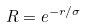Convert formula to latex. <formula><loc_0><loc_0><loc_500><loc_500>R = e ^ { - r / \sigma }</formula> 